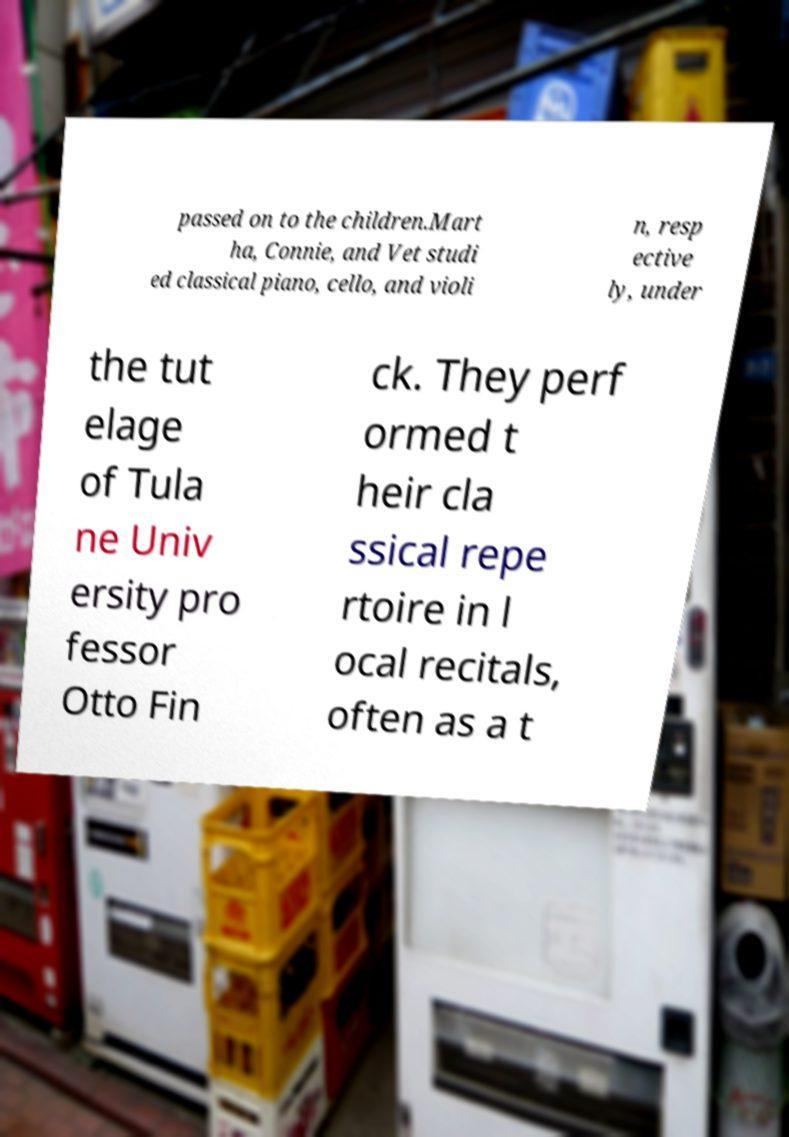Please identify and transcribe the text found in this image. passed on to the children.Mart ha, Connie, and Vet studi ed classical piano, cello, and violi n, resp ective ly, under the tut elage of Tula ne Univ ersity pro fessor Otto Fin ck. They perf ormed t heir cla ssical repe rtoire in l ocal recitals, often as a t 